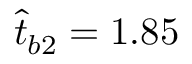<formula> <loc_0><loc_0><loc_500><loc_500>\hat { t } _ { b 2 } = 1 . 8 5</formula> 